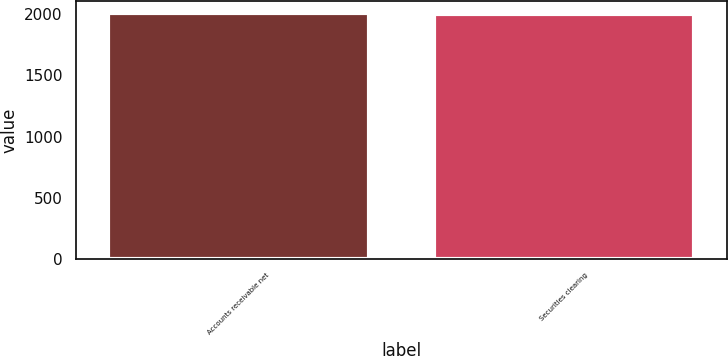Convert chart. <chart><loc_0><loc_0><loc_500><loc_500><bar_chart><fcel>Accounts receivable net<fcel>Securities clearing<nl><fcel>2008<fcel>2000<nl></chart> 